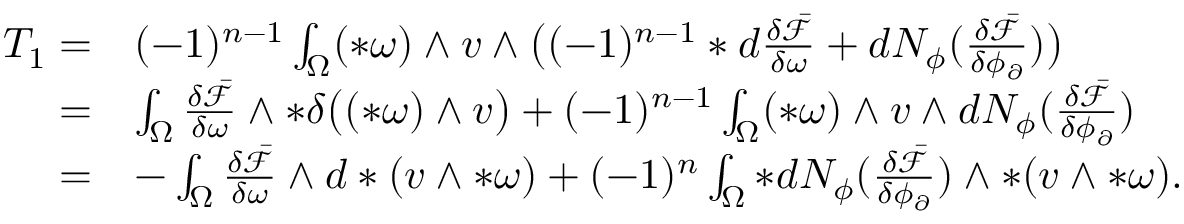Convert formula to latex. <formula><loc_0><loc_0><loc_500><loc_500>\begin{array} { r l } { T _ { 1 } = } & { ( - 1 ) ^ { n - 1 } \int _ { \Omega } ( \ast \omega ) \wedge v \wedge \left ( ( - 1 ) ^ { n - 1 } \ast d \frac { \delta \bar { \mathcal { F } } } { \delta \omega } + d N _ { \phi } ( \frac { \delta \bar { \mathcal { F } } } { \delta \phi _ { \partial } } ) \right ) } \\ { = } & { \int _ { \Omega } \frac { \delta \bar { \mathcal { F } } } { \delta \omega } \wedge \ast \delta \left ( ( \ast \omega ) \wedge v \right ) + ( - 1 ) ^ { n - 1 } \int _ { \Omega } ( \ast \omega ) \wedge v \wedge d N _ { \phi } ( \frac { \delta \bar { \mathcal { F } } } { \delta \phi _ { \partial } } ) } \\ { = } & { - \int _ { \Omega } \frac { \delta \bar { \mathcal { F } } } { \delta \omega } \wedge d \ast ( v \wedge \ast \omega ) + ( - 1 ) ^ { n } \int _ { \Omega } \ast d N _ { \phi } ( \frac { \delta \bar { \mathcal { F } } } { \delta \phi _ { \partial } } ) \wedge \ast ( v \wedge \ast \omega ) . } \end{array}</formula> 